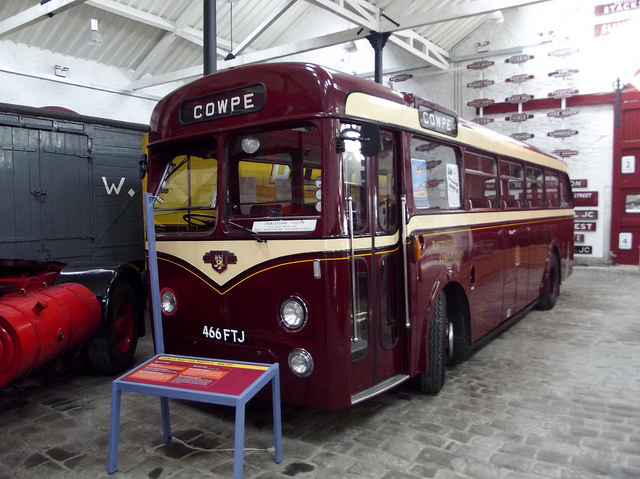Please transcribe the text information in this image. COWPE COWPE 466 FTJ STACK W JC JC 